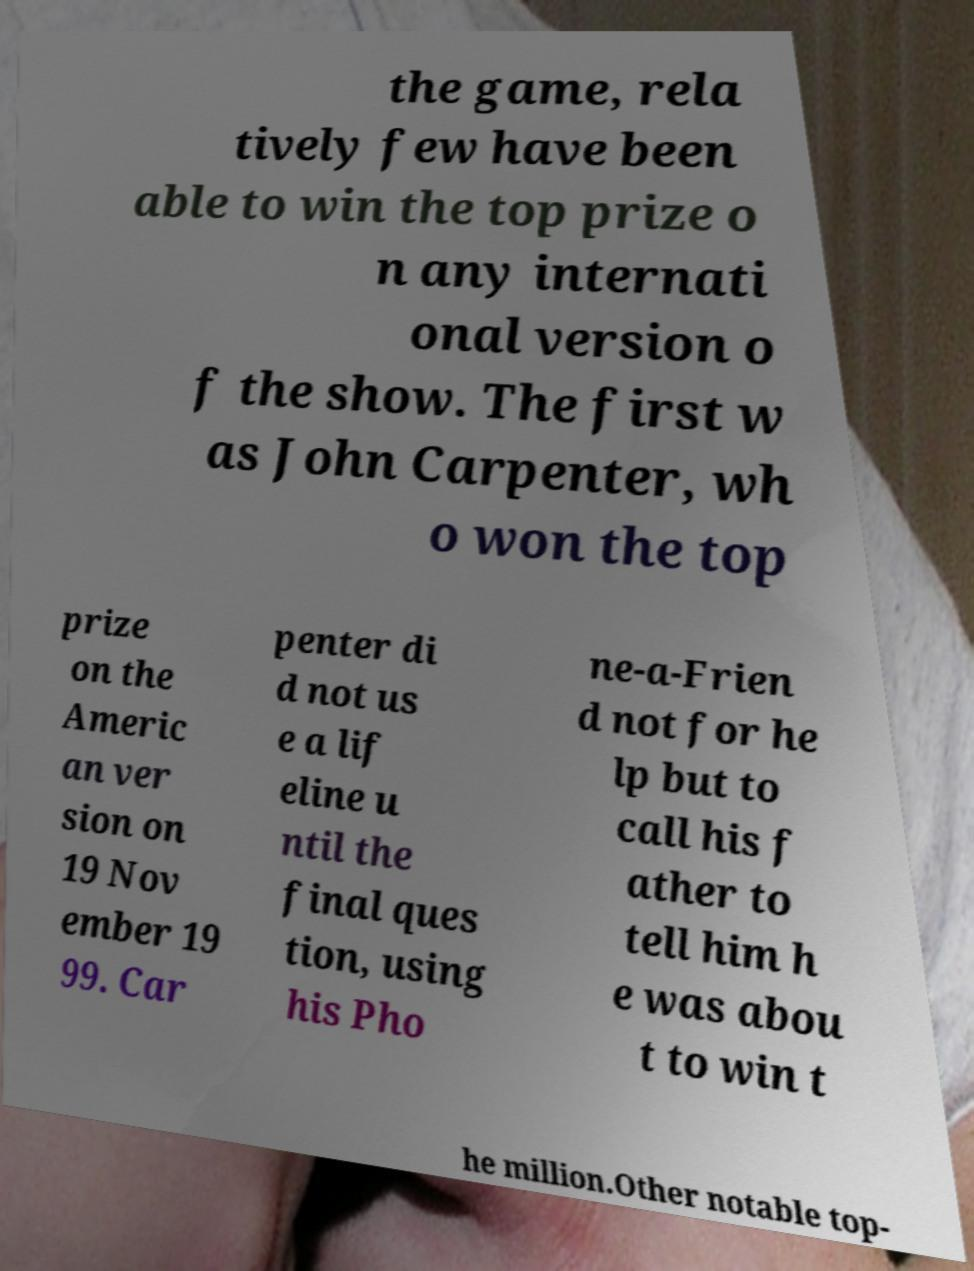Can you read and provide the text displayed in the image?This photo seems to have some interesting text. Can you extract and type it out for me? the game, rela tively few have been able to win the top prize o n any internati onal version o f the show. The first w as John Carpenter, wh o won the top prize on the Americ an ver sion on 19 Nov ember 19 99. Car penter di d not us e a lif eline u ntil the final ques tion, using his Pho ne-a-Frien d not for he lp but to call his f ather to tell him h e was abou t to win t he million.Other notable top- 